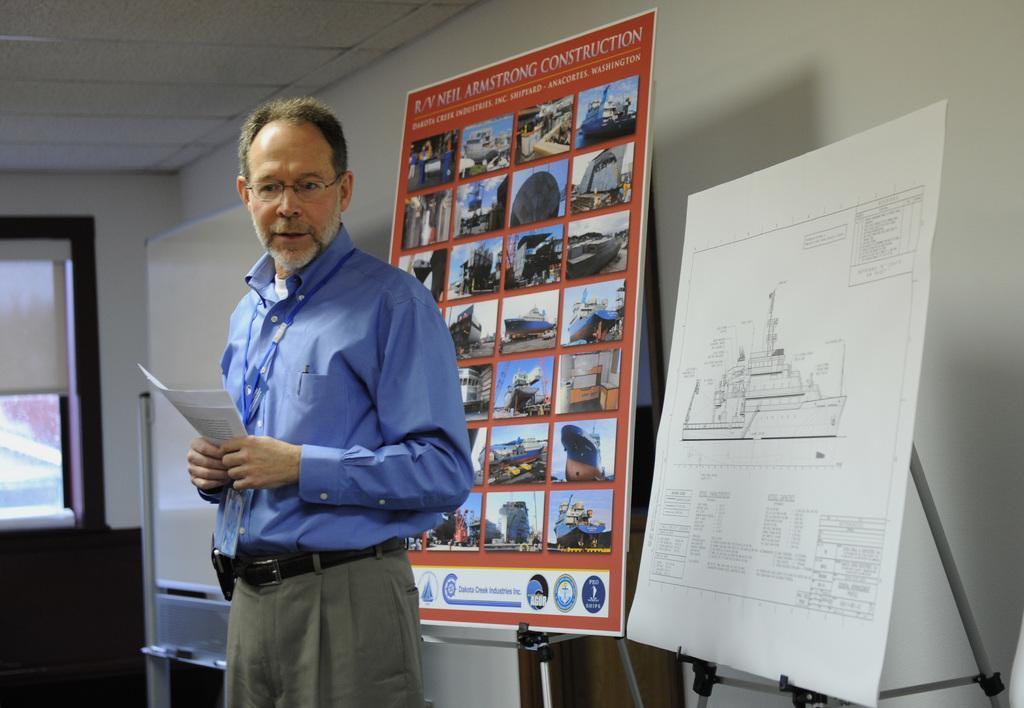Describe this image in one or two sentences. In this image there is a man standing wearing glasses, ID tags and holding papers in his hands, behind him there are boards, on that boards there are picture and some text, behind that boards there is a wall, in the background there a wall for that wall there is a window, at the top there is a ceiling. 